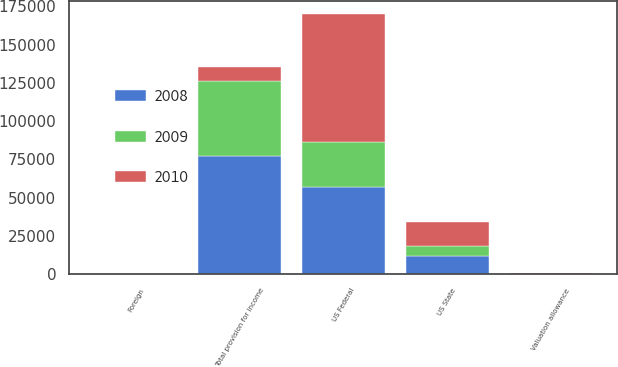Convert chart to OTSL. <chart><loc_0><loc_0><loc_500><loc_500><stacked_bar_chart><ecel><fcel>US Federal<fcel>US State<fcel>Foreign<fcel>Valuation allowance<fcel>Total provision for income<nl><fcel>2010<fcel>83850<fcel>15745<fcel>6<fcel>415<fcel>9331.5<nl><fcel>2008<fcel>56945<fcel>12151<fcel>139<fcel>141<fcel>77380<nl><fcel>2009<fcel>29291<fcel>6512<fcel>53<fcel>89<fcel>49004<nl></chart> 